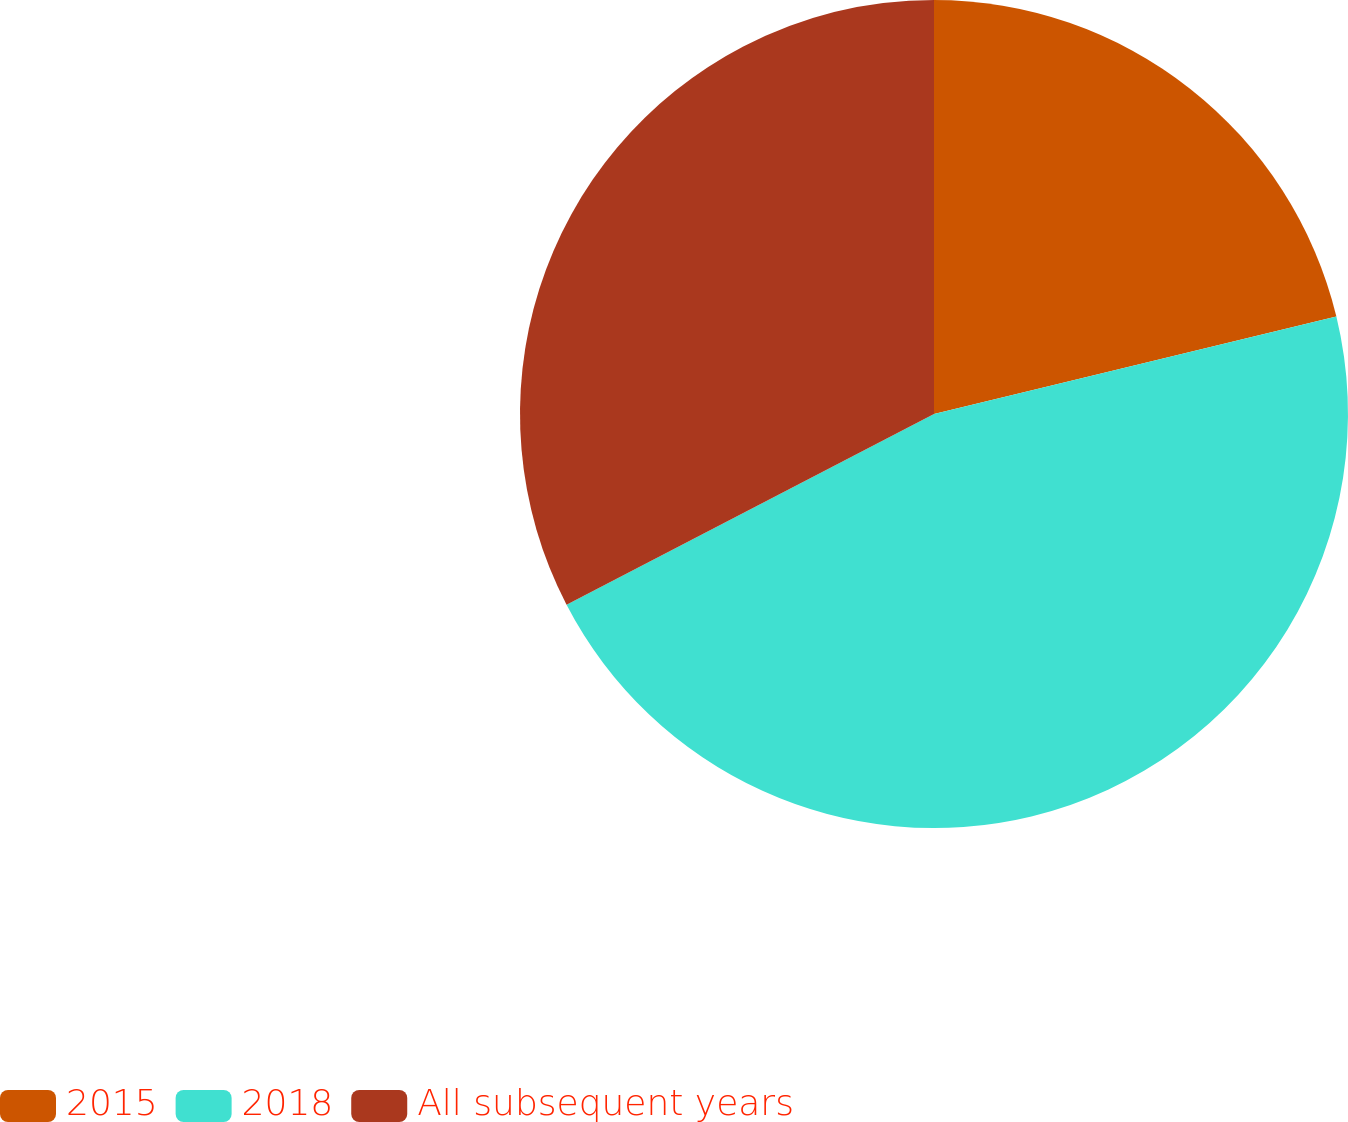Convert chart. <chart><loc_0><loc_0><loc_500><loc_500><pie_chart><fcel>2015<fcel>2018<fcel>All subsequent years<nl><fcel>21.22%<fcel>46.16%<fcel>32.62%<nl></chart> 